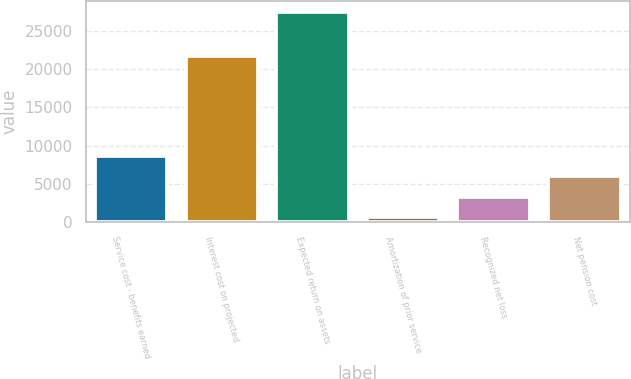Convert chart to OTSL. <chart><loc_0><loc_0><loc_500><loc_500><bar_chart><fcel>Service cost - benefits earned<fcel>Interest cost on projected<fcel>Expected return on assets<fcel>Amortization of prior service<fcel>Recognized net loss<fcel>Net pension cost<nl><fcel>8708<fcel>21790<fcel>27510<fcel>650<fcel>3336<fcel>6022<nl></chart> 